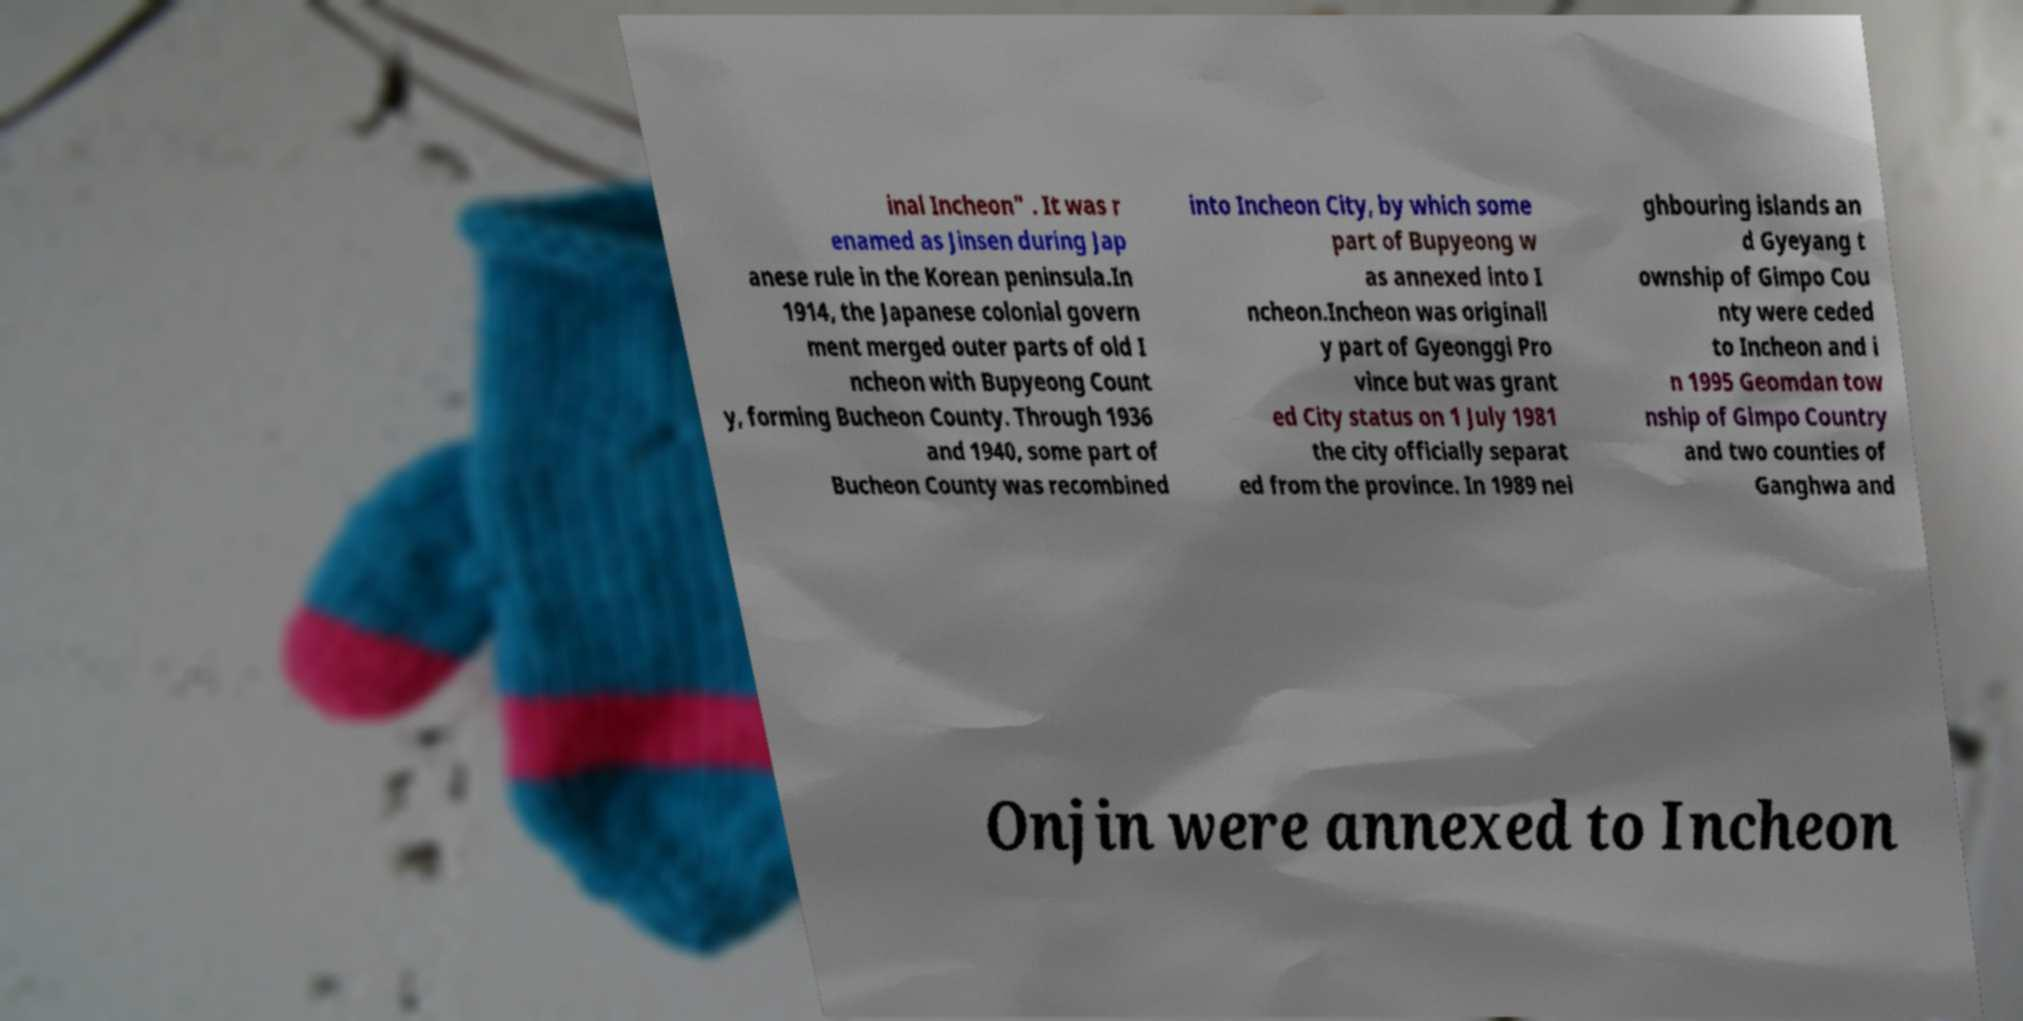Can you read and provide the text displayed in the image?This photo seems to have some interesting text. Can you extract and type it out for me? inal Incheon" . It was r enamed as Jinsen during Jap anese rule in the Korean peninsula.In 1914, the Japanese colonial govern ment merged outer parts of old I ncheon with Bupyeong Count y, forming Bucheon County. Through 1936 and 1940, some part of Bucheon County was recombined into Incheon City, by which some part of Bupyeong w as annexed into I ncheon.Incheon was originall y part of Gyeonggi Pro vince but was grant ed City status on 1 July 1981 the city officially separat ed from the province. In 1989 nei ghbouring islands an d Gyeyang t ownship of Gimpo Cou nty were ceded to Incheon and i n 1995 Geomdan tow nship of Gimpo Country and two counties of Ganghwa and Onjin were annexed to Incheon 